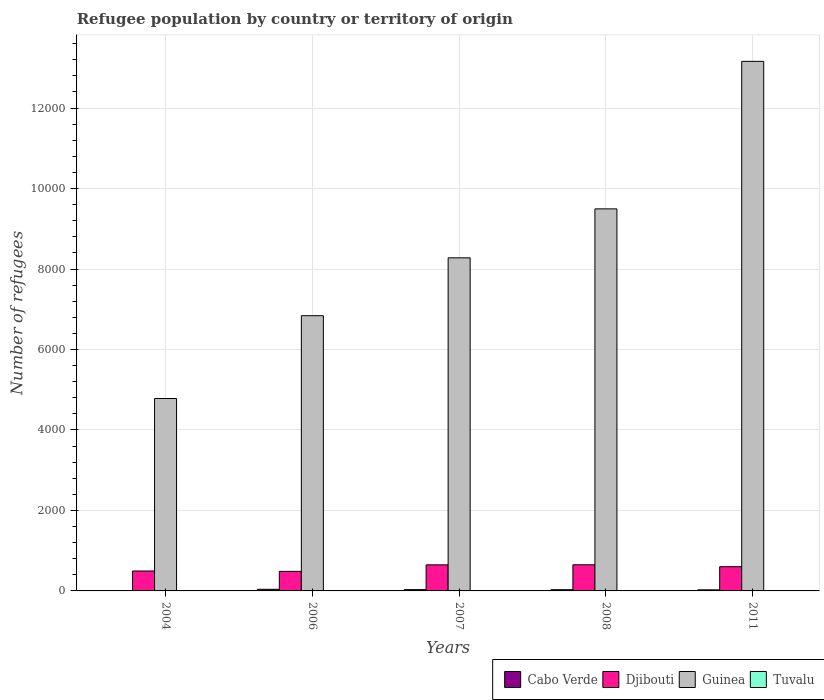How many different coloured bars are there?
Provide a succinct answer. 4. Are the number of bars per tick equal to the number of legend labels?
Give a very brief answer. Yes. Are the number of bars on each tick of the X-axis equal?
Provide a succinct answer. Yes. In how many cases, is the number of bars for a given year not equal to the number of legend labels?
Provide a short and direct response. 0. What is the number of refugees in Guinea in 2006?
Give a very brief answer. 6840. Across all years, what is the maximum number of refugees in Tuvalu?
Give a very brief answer. 3. Across all years, what is the minimum number of refugees in Cabo Verde?
Give a very brief answer. 8. What is the difference between the number of refugees in Guinea in 2006 and that in 2008?
Make the answer very short. -2655. What is the difference between the number of refugees in Guinea in 2011 and the number of refugees in Cabo Verde in 2004?
Your answer should be compact. 1.32e+04. What is the average number of refugees in Guinea per year?
Your answer should be very brief. 8511.2. In the year 2006, what is the difference between the number of refugees in Tuvalu and number of refugees in Djibouti?
Provide a succinct answer. -483. What is the ratio of the number of refugees in Djibouti in 2007 to that in 2011?
Offer a terse response. 1.08. Is the number of refugees in Djibouti in 2008 less than that in 2011?
Offer a very short reply. No. What is the difference between the highest and the second highest number of refugees in Djibouti?
Give a very brief answer. 2. What is the difference between the highest and the lowest number of refugees in Tuvalu?
Your answer should be very brief. 2. In how many years, is the number of refugees in Guinea greater than the average number of refugees in Guinea taken over all years?
Give a very brief answer. 2. What does the 1st bar from the left in 2007 represents?
Make the answer very short. Cabo Verde. What does the 3rd bar from the right in 2007 represents?
Ensure brevity in your answer.  Djibouti. How many bars are there?
Your answer should be compact. 20. Are all the bars in the graph horizontal?
Provide a succinct answer. No. How many years are there in the graph?
Offer a terse response. 5. What is the difference between two consecutive major ticks on the Y-axis?
Ensure brevity in your answer.  2000. Does the graph contain grids?
Give a very brief answer. Yes. Where does the legend appear in the graph?
Provide a succinct answer. Bottom right. What is the title of the graph?
Your answer should be very brief. Refugee population by country or territory of origin. What is the label or title of the Y-axis?
Give a very brief answer. Number of refugees. What is the Number of refugees in Cabo Verde in 2004?
Your answer should be compact. 8. What is the Number of refugees of Djibouti in 2004?
Ensure brevity in your answer.  495. What is the Number of refugees in Guinea in 2004?
Provide a short and direct response. 4782. What is the Number of refugees in Djibouti in 2006?
Provide a short and direct response. 486. What is the Number of refugees in Guinea in 2006?
Offer a terse response. 6840. What is the Number of refugees of Djibouti in 2007?
Give a very brief answer. 648. What is the Number of refugees of Guinea in 2007?
Your response must be concise. 8278. What is the Number of refugees in Tuvalu in 2007?
Keep it short and to the point. 2. What is the Number of refugees in Cabo Verde in 2008?
Provide a succinct answer. 30. What is the Number of refugees of Djibouti in 2008?
Make the answer very short. 650. What is the Number of refugees in Guinea in 2008?
Provide a succinct answer. 9495. What is the Number of refugees in Djibouti in 2011?
Offer a terse response. 602. What is the Number of refugees of Guinea in 2011?
Give a very brief answer. 1.32e+04. What is the Number of refugees in Tuvalu in 2011?
Your answer should be very brief. 1. Across all years, what is the maximum Number of refugees of Djibouti?
Offer a terse response. 650. Across all years, what is the maximum Number of refugees in Guinea?
Offer a very short reply. 1.32e+04. Across all years, what is the minimum Number of refugees in Djibouti?
Keep it short and to the point. 486. Across all years, what is the minimum Number of refugees in Guinea?
Keep it short and to the point. 4782. Across all years, what is the minimum Number of refugees of Tuvalu?
Your response must be concise. 1. What is the total Number of refugees in Cabo Verde in the graph?
Your answer should be compact. 137. What is the total Number of refugees of Djibouti in the graph?
Provide a succinct answer. 2881. What is the total Number of refugees in Guinea in the graph?
Your response must be concise. 4.26e+04. What is the total Number of refugees in Tuvalu in the graph?
Ensure brevity in your answer.  11. What is the difference between the Number of refugees of Cabo Verde in 2004 and that in 2006?
Give a very brief answer. -32. What is the difference between the Number of refugees in Djibouti in 2004 and that in 2006?
Your answer should be compact. 9. What is the difference between the Number of refugees in Guinea in 2004 and that in 2006?
Keep it short and to the point. -2058. What is the difference between the Number of refugees in Djibouti in 2004 and that in 2007?
Offer a terse response. -153. What is the difference between the Number of refugees of Guinea in 2004 and that in 2007?
Your response must be concise. -3496. What is the difference between the Number of refugees of Tuvalu in 2004 and that in 2007?
Offer a terse response. 1. What is the difference between the Number of refugees in Djibouti in 2004 and that in 2008?
Offer a very short reply. -155. What is the difference between the Number of refugees of Guinea in 2004 and that in 2008?
Offer a terse response. -4713. What is the difference between the Number of refugees in Djibouti in 2004 and that in 2011?
Provide a succinct answer. -107. What is the difference between the Number of refugees of Guinea in 2004 and that in 2011?
Provide a succinct answer. -8379. What is the difference between the Number of refugees of Cabo Verde in 2006 and that in 2007?
Ensure brevity in your answer.  8. What is the difference between the Number of refugees in Djibouti in 2006 and that in 2007?
Keep it short and to the point. -162. What is the difference between the Number of refugees of Guinea in 2006 and that in 2007?
Your response must be concise. -1438. What is the difference between the Number of refugees in Djibouti in 2006 and that in 2008?
Make the answer very short. -164. What is the difference between the Number of refugees in Guinea in 2006 and that in 2008?
Ensure brevity in your answer.  -2655. What is the difference between the Number of refugees in Tuvalu in 2006 and that in 2008?
Offer a very short reply. 1. What is the difference between the Number of refugees in Cabo Verde in 2006 and that in 2011?
Make the answer very short. 13. What is the difference between the Number of refugees in Djibouti in 2006 and that in 2011?
Provide a succinct answer. -116. What is the difference between the Number of refugees in Guinea in 2006 and that in 2011?
Offer a very short reply. -6321. What is the difference between the Number of refugees of Tuvalu in 2006 and that in 2011?
Provide a succinct answer. 2. What is the difference between the Number of refugees in Djibouti in 2007 and that in 2008?
Your answer should be compact. -2. What is the difference between the Number of refugees in Guinea in 2007 and that in 2008?
Offer a very short reply. -1217. What is the difference between the Number of refugees in Tuvalu in 2007 and that in 2008?
Your answer should be very brief. 0. What is the difference between the Number of refugees of Djibouti in 2007 and that in 2011?
Your answer should be very brief. 46. What is the difference between the Number of refugees of Guinea in 2007 and that in 2011?
Ensure brevity in your answer.  -4883. What is the difference between the Number of refugees of Cabo Verde in 2008 and that in 2011?
Provide a short and direct response. 3. What is the difference between the Number of refugees in Djibouti in 2008 and that in 2011?
Make the answer very short. 48. What is the difference between the Number of refugees in Guinea in 2008 and that in 2011?
Your answer should be compact. -3666. What is the difference between the Number of refugees in Tuvalu in 2008 and that in 2011?
Keep it short and to the point. 1. What is the difference between the Number of refugees in Cabo Verde in 2004 and the Number of refugees in Djibouti in 2006?
Make the answer very short. -478. What is the difference between the Number of refugees of Cabo Verde in 2004 and the Number of refugees of Guinea in 2006?
Offer a very short reply. -6832. What is the difference between the Number of refugees of Djibouti in 2004 and the Number of refugees of Guinea in 2006?
Ensure brevity in your answer.  -6345. What is the difference between the Number of refugees in Djibouti in 2004 and the Number of refugees in Tuvalu in 2006?
Make the answer very short. 492. What is the difference between the Number of refugees in Guinea in 2004 and the Number of refugees in Tuvalu in 2006?
Your answer should be compact. 4779. What is the difference between the Number of refugees in Cabo Verde in 2004 and the Number of refugees in Djibouti in 2007?
Offer a very short reply. -640. What is the difference between the Number of refugees of Cabo Verde in 2004 and the Number of refugees of Guinea in 2007?
Give a very brief answer. -8270. What is the difference between the Number of refugees of Djibouti in 2004 and the Number of refugees of Guinea in 2007?
Provide a short and direct response. -7783. What is the difference between the Number of refugees of Djibouti in 2004 and the Number of refugees of Tuvalu in 2007?
Your answer should be compact. 493. What is the difference between the Number of refugees in Guinea in 2004 and the Number of refugees in Tuvalu in 2007?
Ensure brevity in your answer.  4780. What is the difference between the Number of refugees in Cabo Verde in 2004 and the Number of refugees in Djibouti in 2008?
Make the answer very short. -642. What is the difference between the Number of refugees in Cabo Verde in 2004 and the Number of refugees in Guinea in 2008?
Ensure brevity in your answer.  -9487. What is the difference between the Number of refugees in Cabo Verde in 2004 and the Number of refugees in Tuvalu in 2008?
Your answer should be compact. 6. What is the difference between the Number of refugees in Djibouti in 2004 and the Number of refugees in Guinea in 2008?
Offer a terse response. -9000. What is the difference between the Number of refugees of Djibouti in 2004 and the Number of refugees of Tuvalu in 2008?
Your answer should be compact. 493. What is the difference between the Number of refugees in Guinea in 2004 and the Number of refugees in Tuvalu in 2008?
Your answer should be compact. 4780. What is the difference between the Number of refugees in Cabo Verde in 2004 and the Number of refugees in Djibouti in 2011?
Offer a very short reply. -594. What is the difference between the Number of refugees of Cabo Verde in 2004 and the Number of refugees of Guinea in 2011?
Ensure brevity in your answer.  -1.32e+04. What is the difference between the Number of refugees of Cabo Verde in 2004 and the Number of refugees of Tuvalu in 2011?
Make the answer very short. 7. What is the difference between the Number of refugees of Djibouti in 2004 and the Number of refugees of Guinea in 2011?
Provide a succinct answer. -1.27e+04. What is the difference between the Number of refugees in Djibouti in 2004 and the Number of refugees in Tuvalu in 2011?
Offer a terse response. 494. What is the difference between the Number of refugees in Guinea in 2004 and the Number of refugees in Tuvalu in 2011?
Offer a very short reply. 4781. What is the difference between the Number of refugees in Cabo Verde in 2006 and the Number of refugees in Djibouti in 2007?
Keep it short and to the point. -608. What is the difference between the Number of refugees in Cabo Verde in 2006 and the Number of refugees in Guinea in 2007?
Offer a terse response. -8238. What is the difference between the Number of refugees in Djibouti in 2006 and the Number of refugees in Guinea in 2007?
Offer a terse response. -7792. What is the difference between the Number of refugees in Djibouti in 2006 and the Number of refugees in Tuvalu in 2007?
Provide a succinct answer. 484. What is the difference between the Number of refugees of Guinea in 2006 and the Number of refugees of Tuvalu in 2007?
Your response must be concise. 6838. What is the difference between the Number of refugees of Cabo Verde in 2006 and the Number of refugees of Djibouti in 2008?
Give a very brief answer. -610. What is the difference between the Number of refugees in Cabo Verde in 2006 and the Number of refugees in Guinea in 2008?
Give a very brief answer. -9455. What is the difference between the Number of refugees in Djibouti in 2006 and the Number of refugees in Guinea in 2008?
Provide a short and direct response. -9009. What is the difference between the Number of refugees in Djibouti in 2006 and the Number of refugees in Tuvalu in 2008?
Give a very brief answer. 484. What is the difference between the Number of refugees of Guinea in 2006 and the Number of refugees of Tuvalu in 2008?
Keep it short and to the point. 6838. What is the difference between the Number of refugees in Cabo Verde in 2006 and the Number of refugees in Djibouti in 2011?
Provide a succinct answer. -562. What is the difference between the Number of refugees in Cabo Verde in 2006 and the Number of refugees in Guinea in 2011?
Ensure brevity in your answer.  -1.31e+04. What is the difference between the Number of refugees in Djibouti in 2006 and the Number of refugees in Guinea in 2011?
Make the answer very short. -1.27e+04. What is the difference between the Number of refugees in Djibouti in 2006 and the Number of refugees in Tuvalu in 2011?
Give a very brief answer. 485. What is the difference between the Number of refugees of Guinea in 2006 and the Number of refugees of Tuvalu in 2011?
Your answer should be compact. 6839. What is the difference between the Number of refugees in Cabo Verde in 2007 and the Number of refugees in Djibouti in 2008?
Your answer should be very brief. -618. What is the difference between the Number of refugees in Cabo Verde in 2007 and the Number of refugees in Guinea in 2008?
Offer a terse response. -9463. What is the difference between the Number of refugees in Djibouti in 2007 and the Number of refugees in Guinea in 2008?
Your response must be concise. -8847. What is the difference between the Number of refugees in Djibouti in 2007 and the Number of refugees in Tuvalu in 2008?
Your response must be concise. 646. What is the difference between the Number of refugees of Guinea in 2007 and the Number of refugees of Tuvalu in 2008?
Give a very brief answer. 8276. What is the difference between the Number of refugees of Cabo Verde in 2007 and the Number of refugees of Djibouti in 2011?
Your answer should be compact. -570. What is the difference between the Number of refugees in Cabo Verde in 2007 and the Number of refugees in Guinea in 2011?
Your answer should be very brief. -1.31e+04. What is the difference between the Number of refugees in Cabo Verde in 2007 and the Number of refugees in Tuvalu in 2011?
Make the answer very short. 31. What is the difference between the Number of refugees of Djibouti in 2007 and the Number of refugees of Guinea in 2011?
Make the answer very short. -1.25e+04. What is the difference between the Number of refugees in Djibouti in 2007 and the Number of refugees in Tuvalu in 2011?
Offer a terse response. 647. What is the difference between the Number of refugees of Guinea in 2007 and the Number of refugees of Tuvalu in 2011?
Provide a short and direct response. 8277. What is the difference between the Number of refugees of Cabo Verde in 2008 and the Number of refugees of Djibouti in 2011?
Provide a succinct answer. -572. What is the difference between the Number of refugees in Cabo Verde in 2008 and the Number of refugees in Guinea in 2011?
Your answer should be very brief. -1.31e+04. What is the difference between the Number of refugees in Cabo Verde in 2008 and the Number of refugees in Tuvalu in 2011?
Ensure brevity in your answer.  29. What is the difference between the Number of refugees in Djibouti in 2008 and the Number of refugees in Guinea in 2011?
Ensure brevity in your answer.  -1.25e+04. What is the difference between the Number of refugees of Djibouti in 2008 and the Number of refugees of Tuvalu in 2011?
Ensure brevity in your answer.  649. What is the difference between the Number of refugees in Guinea in 2008 and the Number of refugees in Tuvalu in 2011?
Offer a terse response. 9494. What is the average Number of refugees in Cabo Verde per year?
Your answer should be very brief. 27.4. What is the average Number of refugees in Djibouti per year?
Your answer should be very brief. 576.2. What is the average Number of refugees of Guinea per year?
Offer a very short reply. 8511.2. In the year 2004, what is the difference between the Number of refugees of Cabo Verde and Number of refugees of Djibouti?
Your answer should be compact. -487. In the year 2004, what is the difference between the Number of refugees in Cabo Verde and Number of refugees in Guinea?
Your response must be concise. -4774. In the year 2004, what is the difference between the Number of refugees of Cabo Verde and Number of refugees of Tuvalu?
Ensure brevity in your answer.  5. In the year 2004, what is the difference between the Number of refugees in Djibouti and Number of refugees in Guinea?
Provide a succinct answer. -4287. In the year 2004, what is the difference between the Number of refugees of Djibouti and Number of refugees of Tuvalu?
Your answer should be compact. 492. In the year 2004, what is the difference between the Number of refugees in Guinea and Number of refugees in Tuvalu?
Make the answer very short. 4779. In the year 2006, what is the difference between the Number of refugees of Cabo Verde and Number of refugees of Djibouti?
Make the answer very short. -446. In the year 2006, what is the difference between the Number of refugees in Cabo Verde and Number of refugees in Guinea?
Offer a terse response. -6800. In the year 2006, what is the difference between the Number of refugees in Cabo Verde and Number of refugees in Tuvalu?
Your answer should be very brief. 37. In the year 2006, what is the difference between the Number of refugees of Djibouti and Number of refugees of Guinea?
Ensure brevity in your answer.  -6354. In the year 2006, what is the difference between the Number of refugees of Djibouti and Number of refugees of Tuvalu?
Ensure brevity in your answer.  483. In the year 2006, what is the difference between the Number of refugees of Guinea and Number of refugees of Tuvalu?
Your answer should be compact. 6837. In the year 2007, what is the difference between the Number of refugees in Cabo Verde and Number of refugees in Djibouti?
Your response must be concise. -616. In the year 2007, what is the difference between the Number of refugees in Cabo Verde and Number of refugees in Guinea?
Your response must be concise. -8246. In the year 2007, what is the difference between the Number of refugees in Djibouti and Number of refugees in Guinea?
Your answer should be very brief. -7630. In the year 2007, what is the difference between the Number of refugees of Djibouti and Number of refugees of Tuvalu?
Your answer should be compact. 646. In the year 2007, what is the difference between the Number of refugees in Guinea and Number of refugees in Tuvalu?
Your response must be concise. 8276. In the year 2008, what is the difference between the Number of refugees in Cabo Verde and Number of refugees in Djibouti?
Your answer should be compact. -620. In the year 2008, what is the difference between the Number of refugees of Cabo Verde and Number of refugees of Guinea?
Make the answer very short. -9465. In the year 2008, what is the difference between the Number of refugees of Djibouti and Number of refugees of Guinea?
Provide a succinct answer. -8845. In the year 2008, what is the difference between the Number of refugees of Djibouti and Number of refugees of Tuvalu?
Keep it short and to the point. 648. In the year 2008, what is the difference between the Number of refugees in Guinea and Number of refugees in Tuvalu?
Offer a terse response. 9493. In the year 2011, what is the difference between the Number of refugees in Cabo Verde and Number of refugees in Djibouti?
Your response must be concise. -575. In the year 2011, what is the difference between the Number of refugees of Cabo Verde and Number of refugees of Guinea?
Your answer should be compact. -1.31e+04. In the year 2011, what is the difference between the Number of refugees in Djibouti and Number of refugees in Guinea?
Provide a succinct answer. -1.26e+04. In the year 2011, what is the difference between the Number of refugees of Djibouti and Number of refugees of Tuvalu?
Ensure brevity in your answer.  601. In the year 2011, what is the difference between the Number of refugees of Guinea and Number of refugees of Tuvalu?
Offer a terse response. 1.32e+04. What is the ratio of the Number of refugees of Cabo Verde in 2004 to that in 2006?
Provide a short and direct response. 0.2. What is the ratio of the Number of refugees in Djibouti in 2004 to that in 2006?
Ensure brevity in your answer.  1.02. What is the ratio of the Number of refugees of Guinea in 2004 to that in 2006?
Your answer should be very brief. 0.7. What is the ratio of the Number of refugees in Tuvalu in 2004 to that in 2006?
Your response must be concise. 1. What is the ratio of the Number of refugees of Cabo Verde in 2004 to that in 2007?
Your answer should be very brief. 0.25. What is the ratio of the Number of refugees of Djibouti in 2004 to that in 2007?
Provide a short and direct response. 0.76. What is the ratio of the Number of refugees of Guinea in 2004 to that in 2007?
Offer a very short reply. 0.58. What is the ratio of the Number of refugees in Tuvalu in 2004 to that in 2007?
Offer a very short reply. 1.5. What is the ratio of the Number of refugees in Cabo Verde in 2004 to that in 2008?
Your response must be concise. 0.27. What is the ratio of the Number of refugees in Djibouti in 2004 to that in 2008?
Offer a very short reply. 0.76. What is the ratio of the Number of refugees of Guinea in 2004 to that in 2008?
Your answer should be very brief. 0.5. What is the ratio of the Number of refugees of Cabo Verde in 2004 to that in 2011?
Provide a short and direct response. 0.3. What is the ratio of the Number of refugees of Djibouti in 2004 to that in 2011?
Ensure brevity in your answer.  0.82. What is the ratio of the Number of refugees in Guinea in 2004 to that in 2011?
Your answer should be compact. 0.36. What is the ratio of the Number of refugees of Cabo Verde in 2006 to that in 2007?
Offer a very short reply. 1.25. What is the ratio of the Number of refugees of Djibouti in 2006 to that in 2007?
Offer a very short reply. 0.75. What is the ratio of the Number of refugees of Guinea in 2006 to that in 2007?
Give a very brief answer. 0.83. What is the ratio of the Number of refugees in Djibouti in 2006 to that in 2008?
Your response must be concise. 0.75. What is the ratio of the Number of refugees of Guinea in 2006 to that in 2008?
Your answer should be very brief. 0.72. What is the ratio of the Number of refugees in Cabo Verde in 2006 to that in 2011?
Your answer should be very brief. 1.48. What is the ratio of the Number of refugees of Djibouti in 2006 to that in 2011?
Make the answer very short. 0.81. What is the ratio of the Number of refugees in Guinea in 2006 to that in 2011?
Make the answer very short. 0.52. What is the ratio of the Number of refugees in Cabo Verde in 2007 to that in 2008?
Ensure brevity in your answer.  1.07. What is the ratio of the Number of refugees of Djibouti in 2007 to that in 2008?
Your response must be concise. 1. What is the ratio of the Number of refugees of Guinea in 2007 to that in 2008?
Your answer should be compact. 0.87. What is the ratio of the Number of refugees of Tuvalu in 2007 to that in 2008?
Give a very brief answer. 1. What is the ratio of the Number of refugees of Cabo Verde in 2007 to that in 2011?
Your response must be concise. 1.19. What is the ratio of the Number of refugees in Djibouti in 2007 to that in 2011?
Provide a short and direct response. 1.08. What is the ratio of the Number of refugees of Guinea in 2007 to that in 2011?
Make the answer very short. 0.63. What is the ratio of the Number of refugees of Tuvalu in 2007 to that in 2011?
Ensure brevity in your answer.  2. What is the ratio of the Number of refugees of Cabo Verde in 2008 to that in 2011?
Provide a succinct answer. 1.11. What is the ratio of the Number of refugees in Djibouti in 2008 to that in 2011?
Your answer should be very brief. 1.08. What is the ratio of the Number of refugees in Guinea in 2008 to that in 2011?
Your answer should be very brief. 0.72. What is the ratio of the Number of refugees of Tuvalu in 2008 to that in 2011?
Your answer should be very brief. 2. What is the difference between the highest and the second highest Number of refugees of Djibouti?
Offer a terse response. 2. What is the difference between the highest and the second highest Number of refugees in Guinea?
Provide a short and direct response. 3666. What is the difference between the highest and the second highest Number of refugees of Tuvalu?
Your response must be concise. 0. What is the difference between the highest and the lowest Number of refugees of Cabo Verde?
Provide a succinct answer. 32. What is the difference between the highest and the lowest Number of refugees of Djibouti?
Your answer should be compact. 164. What is the difference between the highest and the lowest Number of refugees of Guinea?
Offer a terse response. 8379. What is the difference between the highest and the lowest Number of refugees in Tuvalu?
Offer a terse response. 2. 